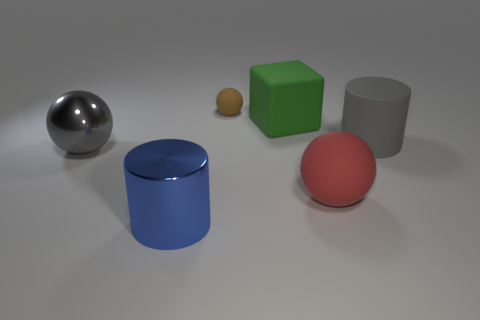Is there any other thing that is the same size as the brown thing?
Give a very brief answer. No. Does the tiny object have the same material as the blue object?
Offer a very short reply. No. The thing that is in front of the small rubber ball and behind the large gray cylinder is what color?
Offer a terse response. Green. Is the color of the cylinder right of the tiny ball the same as the metal ball?
Offer a very short reply. Yes. There is a red object that is the same size as the blue shiny cylinder; what shape is it?
Offer a terse response. Sphere. What number of other objects are the same color as the cube?
Your answer should be compact. 0. What number of other things are there of the same material as the gray cylinder
Keep it short and to the point. 3. Do the gray metal sphere and the cylinder that is left of the brown thing have the same size?
Provide a short and direct response. Yes. What color is the tiny matte object?
Your response must be concise. Brown. The big object on the left side of the cylinder that is to the left of the large gray thing to the right of the red rubber ball is what shape?
Provide a short and direct response. Sphere. 